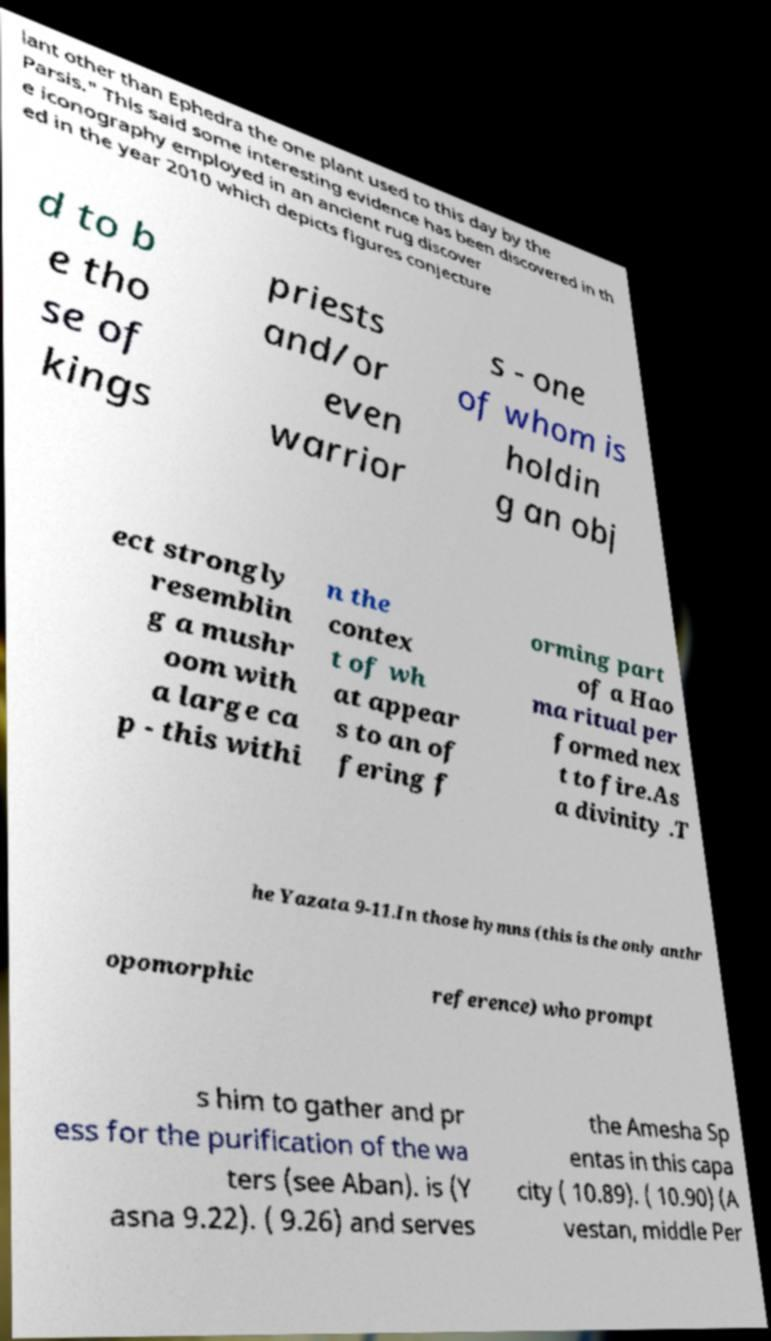Could you extract and type out the text from this image? lant other than Ephedra the one plant used to this day by the Parsis." This said some interesting evidence has been discovered in th e iconography employed in an ancient rug discover ed in the year 2010 which depicts figures conjecture d to b e tho se of kings priests and/or even warrior s - one of whom is holdin g an obj ect strongly resemblin g a mushr oom with a large ca p - this withi n the contex t of wh at appear s to an of fering f orming part of a Hao ma ritual per formed nex t to fire.As a divinity .T he Yazata 9-11.In those hymns (this is the only anthr opomorphic reference) who prompt s him to gather and pr ess for the purification of the wa ters (see Aban). is (Y asna 9.22). ( 9.26) and serves the Amesha Sp entas in this capa city ( 10.89). ( 10.90) (A vestan, middle Per 